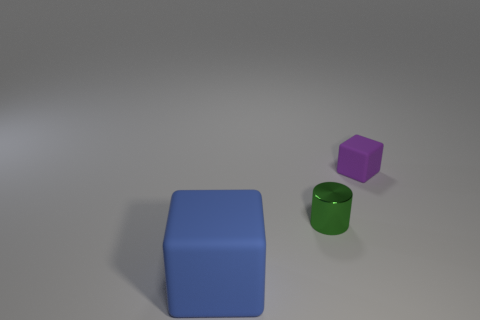Is there any other thing that has the same size as the blue rubber thing?
Offer a very short reply. No. Are there any large things that have the same color as the shiny cylinder?
Your answer should be very brief. No. There is a block in front of the small metal object; is its color the same as the rubber thing behind the large blue matte thing?
Your response must be concise. No. What is the object left of the green shiny thing made of?
Keep it short and to the point. Rubber. There is another thing that is the same material as the tiny purple object; what color is it?
Provide a succinct answer. Blue. What number of other blue things have the same size as the shiny thing?
Your answer should be compact. 0. Do the matte cube that is on the right side of the shiny thing and the shiny thing have the same size?
Provide a succinct answer. Yes. There is a object that is both behind the blue block and left of the small rubber block; what is its shape?
Ensure brevity in your answer.  Cylinder. There is a small cylinder; are there any small green cylinders behind it?
Your answer should be compact. No. Is there anything else that is the same shape as the tiny purple matte thing?
Provide a succinct answer. Yes. 